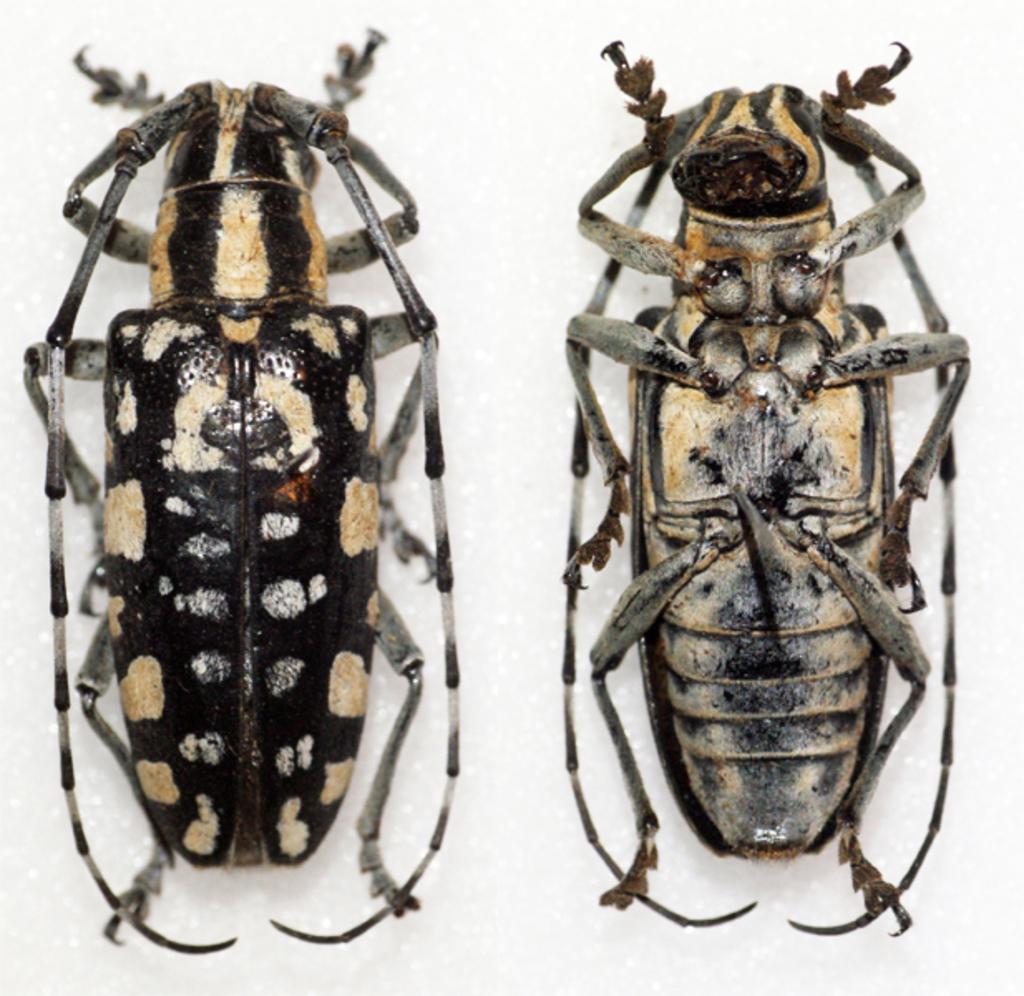Describe this image in one or two sentences. In this picture we can see two cockroaches on a white surface. 